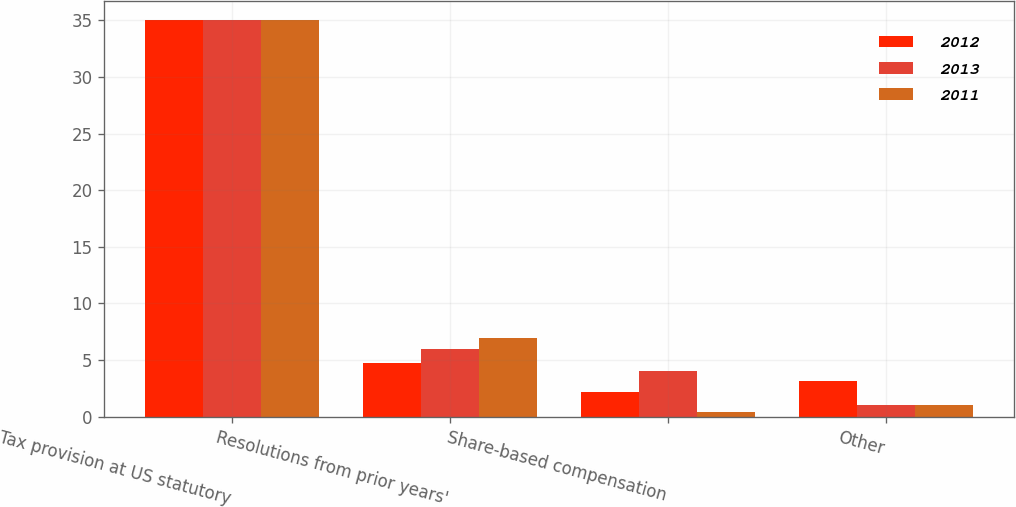Convert chart to OTSL. <chart><loc_0><loc_0><loc_500><loc_500><stacked_bar_chart><ecel><fcel>Tax provision at US statutory<fcel>Resolutions from prior years'<fcel>Share-based compensation<fcel>Other<nl><fcel>2012<fcel>35<fcel>4.7<fcel>2.2<fcel>3.1<nl><fcel>2013<fcel>35<fcel>6<fcel>4<fcel>1<nl><fcel>2011<fcel>35<fcel>6.9<fcel>0.4<fcel>1<nl></chart> 